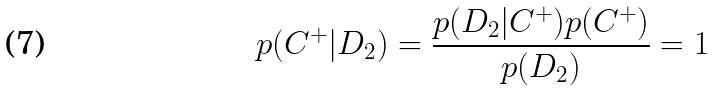<formula> <loc_0><loc_0><loc_500><loc_500>p ( C ^ { + } | D _ { 2 } ) = \frac { p ( D _ { 2 } | C ^ { + } ) p ( C ^ { + } ) } { p ( D _ { 2 } ) } = 1</formula> 